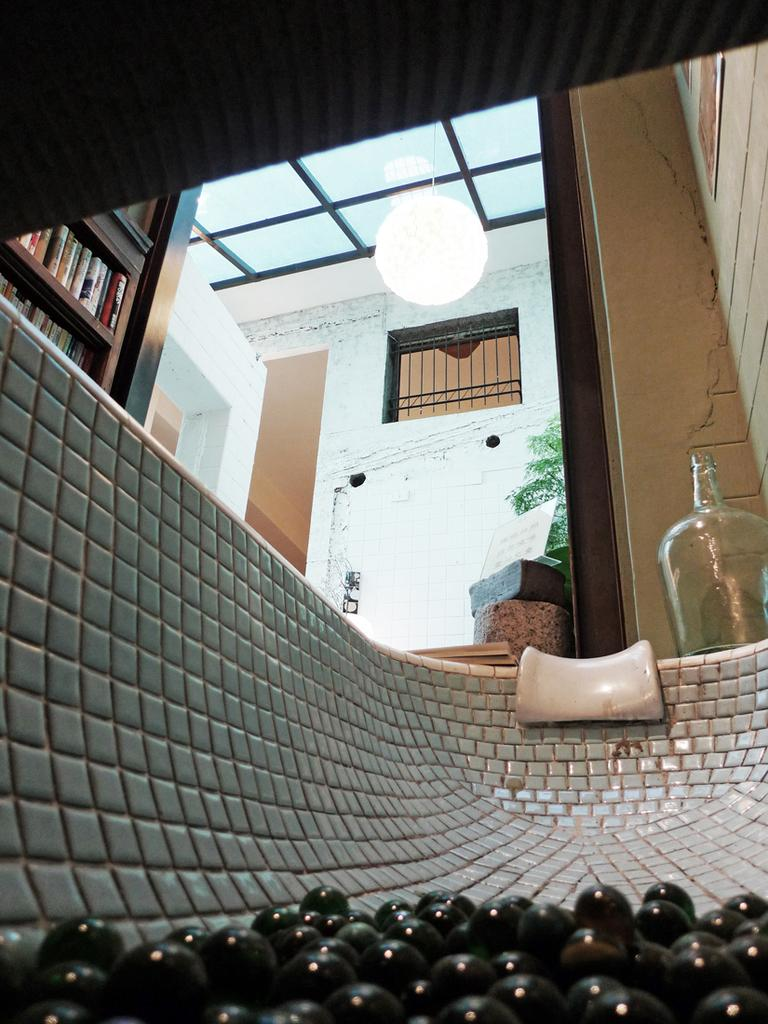What objects are in the tub in the image? There are black balls in a tub in the image. What other object can be seen in the image? There is a jar in the image. What type of items are present in the image that are not related to the tub or jar? There are books in the image. What can be seen in the background of the image? There is a wall visible in the background of the image. Are there any islands visible in the image? No, there are no islands present in the image. Can you find a receipt in the image? No, there is no receipt present in the image. 